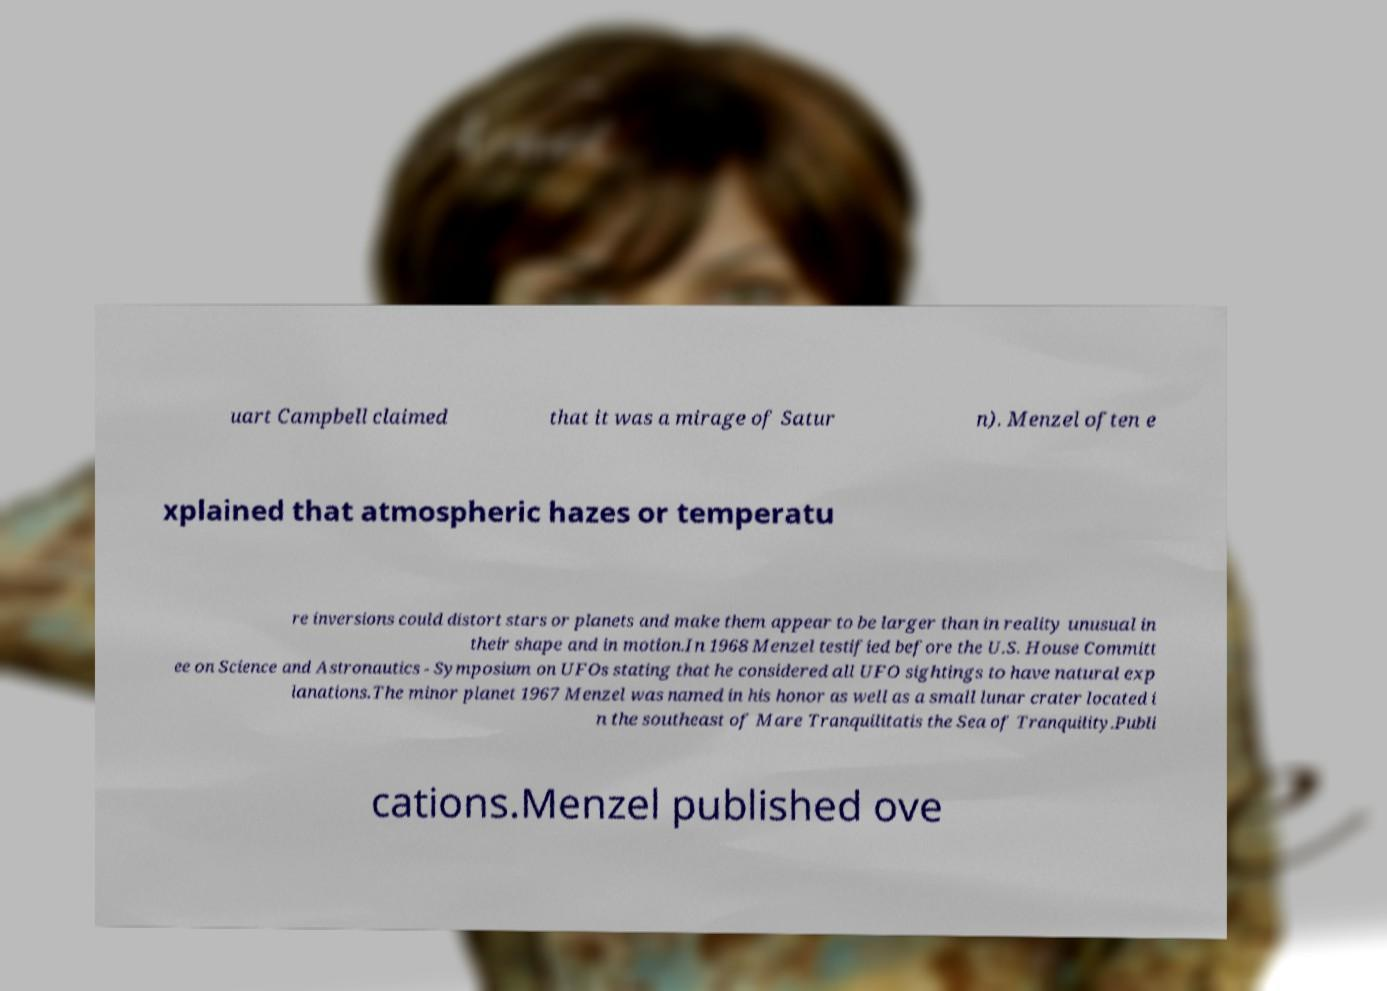Could you assist in decoding the text presented in this image and type it out clearly? uart Campbell claimed that it was a mirage of Satur n). Menzel often e xplained that atmospheric hazes or temperatu re inversions could distort stars or planets and make them appear to be larger than in reality unusual in their shape and in motion.In 1968 Menzel testified before the U.S. House Committ ee on Science and Astronautics - Symposium on UFOs stating that he considered all UFO sightings to have natural exp lanations.The minor planet 1967 Menzel was named in his honor as well as a small lunar crater located i n the southeast of Mare Tranquilitatis the Sea of Tranquility.Publi cations.Menzel published ove 